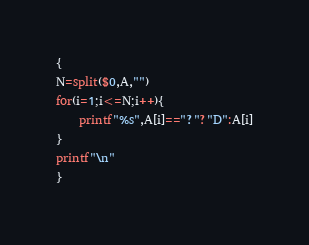Convert code to text. <code><loc_0><loc_0><loc_500><loc_500><_Awk_>{
N=split($0,A,"")
for(i=1;i<=N;i++){
	printf"%s",A[i]=="?"?"D":A[i]
}
printf"\n"
}</code> 